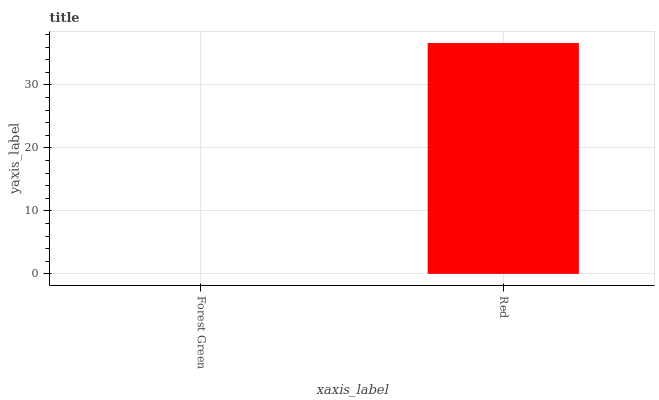Is Forest Green the minimum?
Answer yes or no. Yes. Is Red the maximum?
Answer yes or no. Yes. Is Red the minimum?
Answer yes or no. No. Is Red greater than Forest Green?
Answer yes or no. Yes. Is Forest Green less than Red?
Answer yes or no. Yes. Is Forest Green greater than Red?
Answer yes or no. No. Is Red less than Forest Green?
Answer yes or no. No. Is Red the high median?
Answer yes or no. Yes. Is Forest Green the low median?
Answer yes or no. Yes. Is Forest Green the high median?
Answer yes or no. No. Is Red the low median?
Answer yes or no. No. 